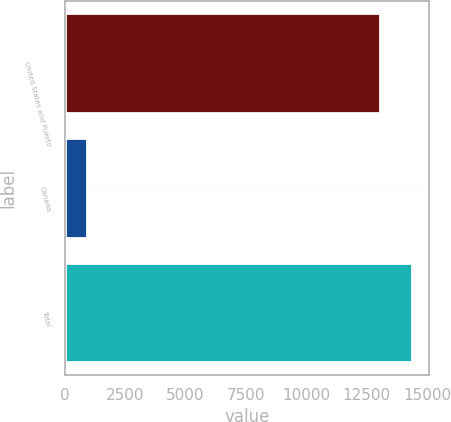<chart> <loc_0><loc_0><loc_500><loc_500><bar_chart><fcel>United States and Puerto<fcel>Canada<fcel>Total<nl><fcel>13064<fcel>932<fcel>14370.4<nl></chart> 